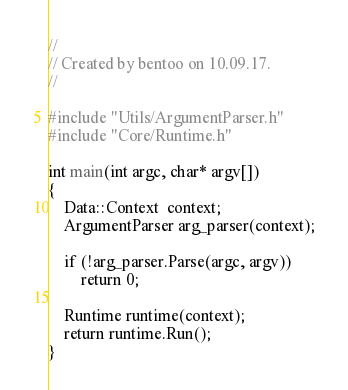Convert code to text. <code><loc_0><loc_0><loc_500><loc_500><_C++_>//
// Created by bentoo on 10.09.17.
//

#include "Utils/ArgumentParser.h"
#include "Core/Runtime.h"

int main(int argc, char* argv[])
{
    Data::Context  context;
    ArgumentParser arg_parser(context);

    if (!arg_parser.Parse(argc, argv))
        return 0;

    Runtime runtime(context);
    return runtime.Run();
}
</code> 